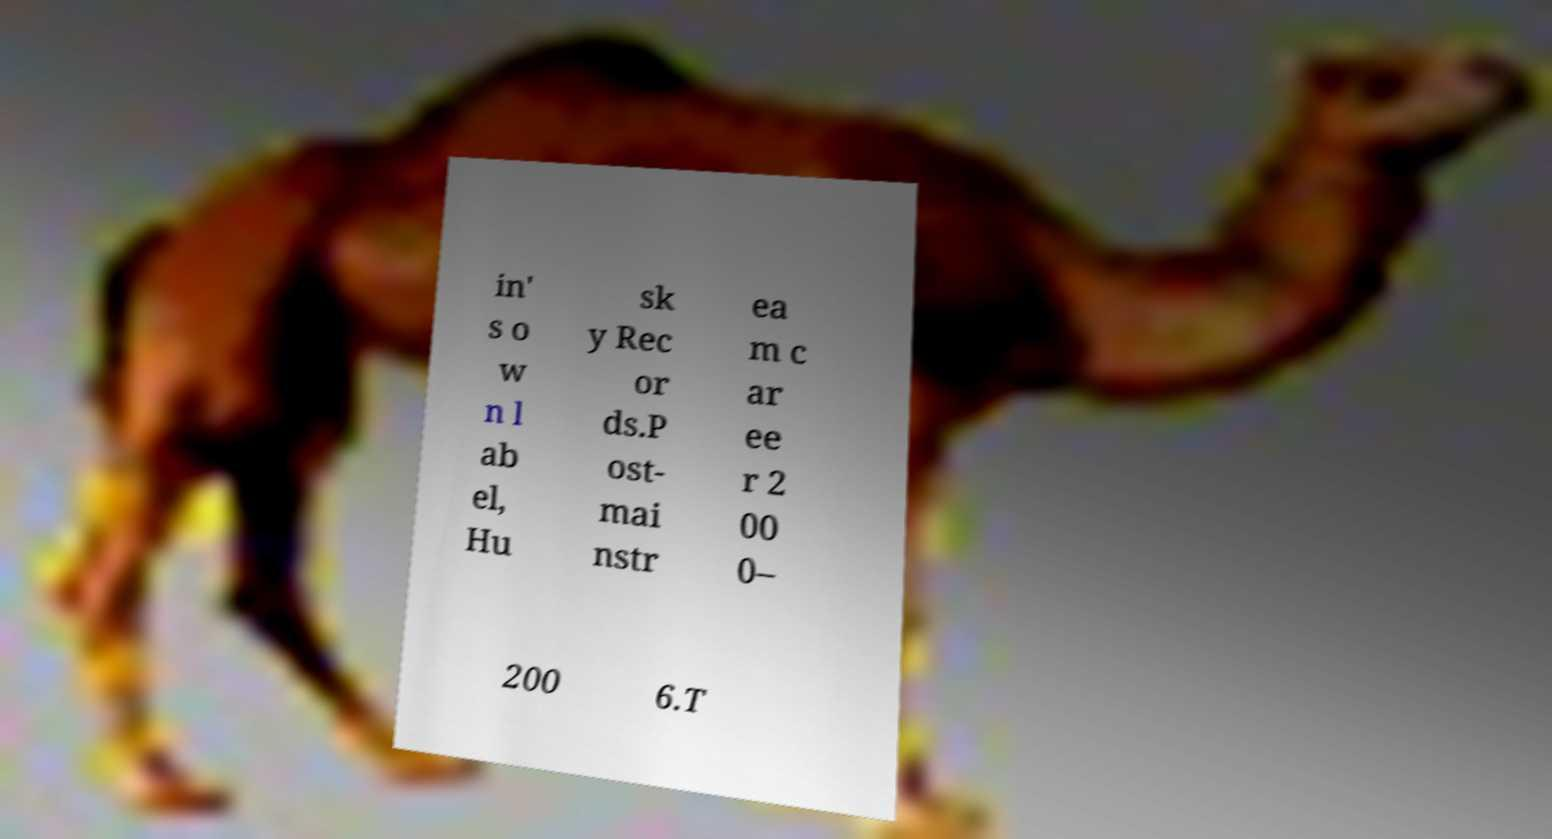Could you extract and type out the text from this image? in' s o w n l ab el, Hu sk y Rec or ds.P ost- mai nstr ea m c ar ee r 2 00 0– 200 6.T 